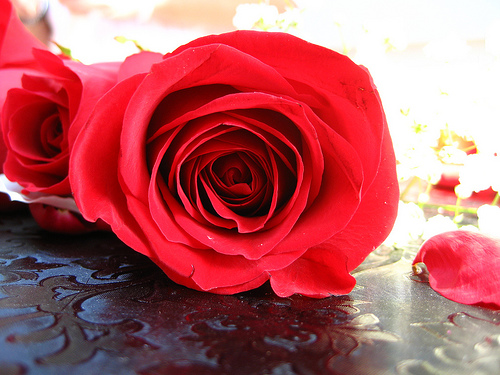<image>
Can you confirm if the flower is in the table? No. The flower is not contained within the table. These objects have a different spatial relationship. 